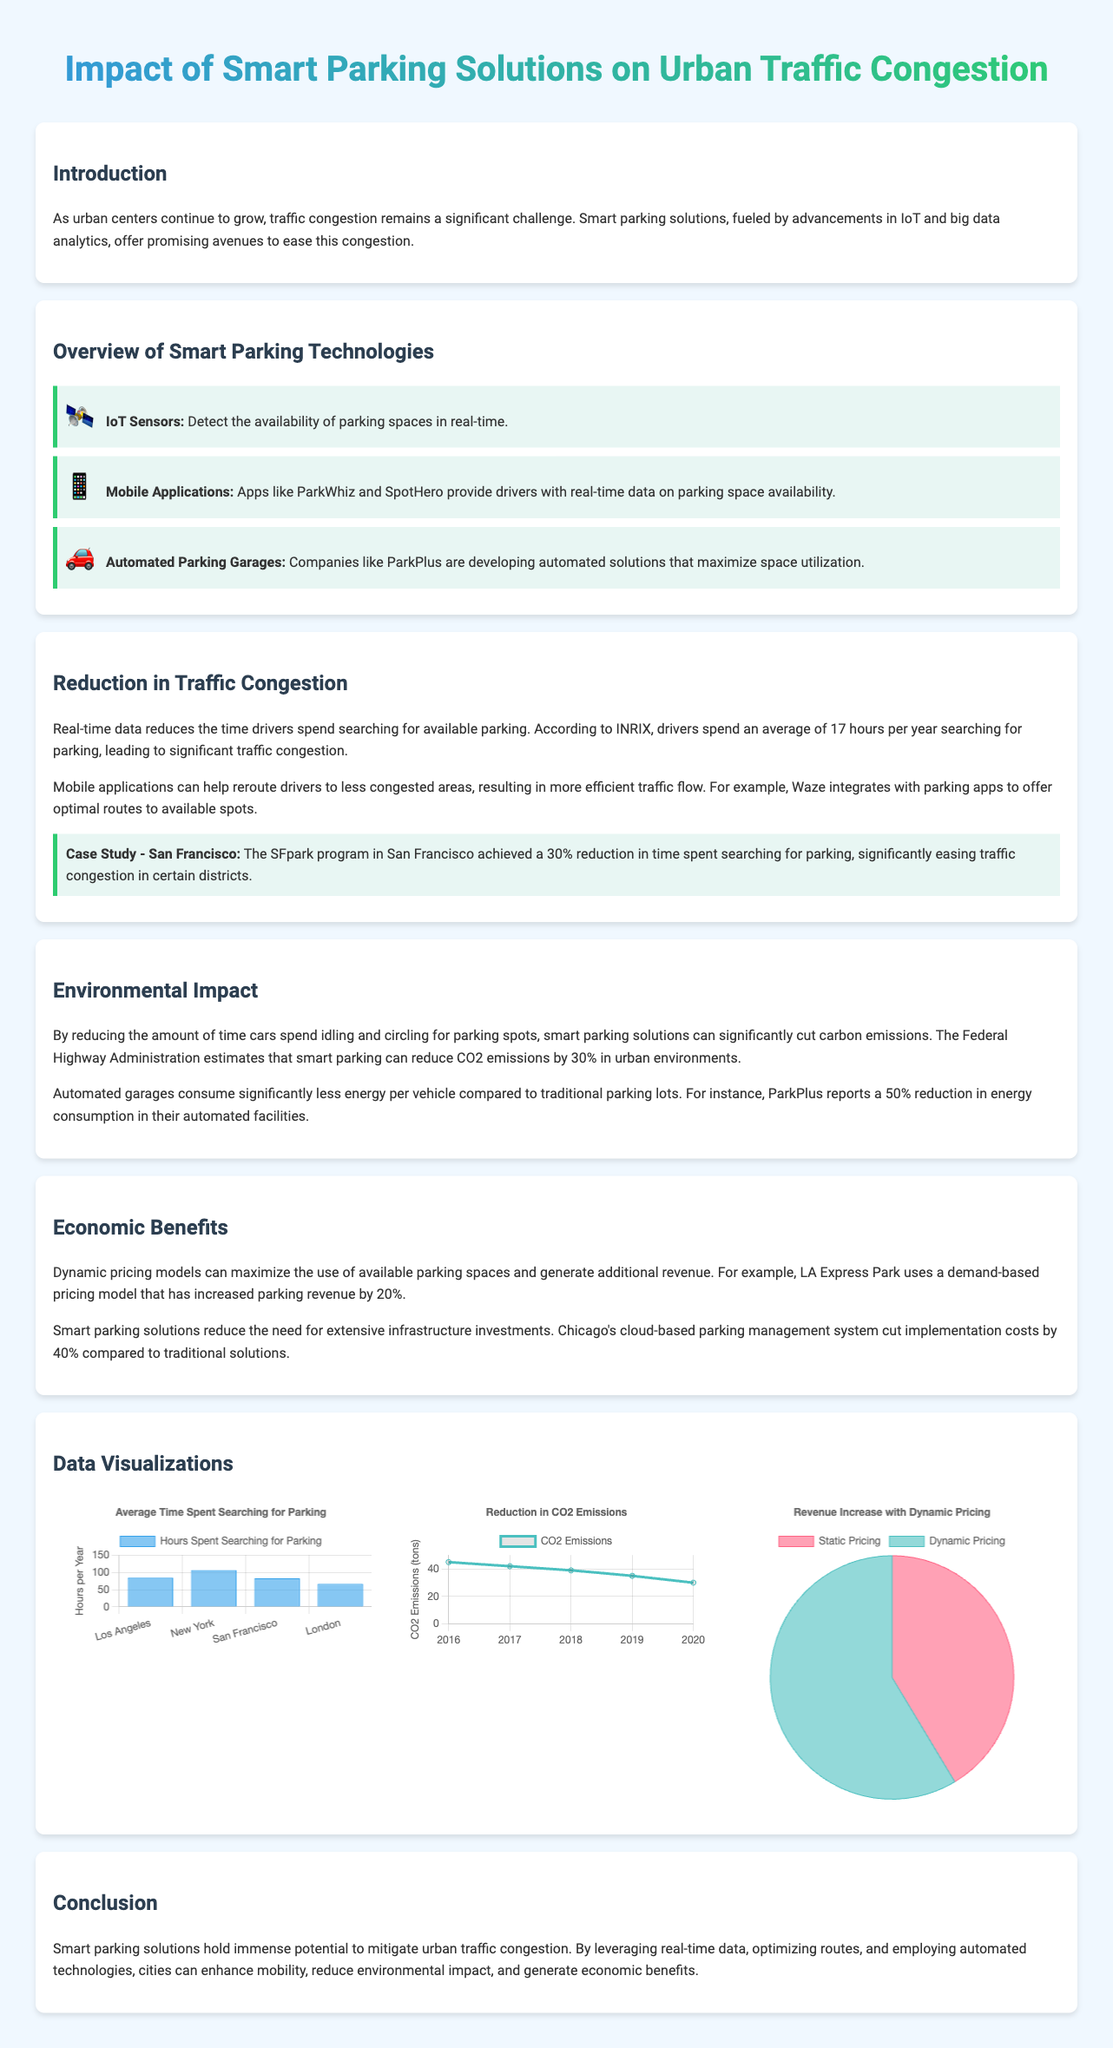What is the average time spent by drivers in Los Angeles searching for parking? The document states that drivers in Los Angeles spend 85 hours per year searching for parking.
Answer: 85 hours What percentage reduction in time spent searching for parking was achieved by the SFpark program? The document mentions a 30% reduction in time spent searching for parking due to the SFpark program.
Answer: 30% What is the CO2 emissions reduction reported in 2020? The data visualization indicates that CO2 emissions were at 30 tons in 2020.
Answer: 30 tons What is the increase in parking revenue due to the LA Express Park's demand-based pricing model? The document states that the demand-based pricing model increased parking revenue by 20%.
Answer: 20% What type of chart shows the average time spent searching for parking? The average time spent searching for parking is represented by a bar chart.
Answer: Bar chart How much energy consumption is reduced in ParkPlus automated facilities compared to traditional parking lots? The document states that ParkPlus reports a 50% reduction in energy consumption in automated facilities.
Answer: 50% What was the CO2 emissions data for the year 2016? The line chart shows that CO2 emissions were 45 tons in 2016.
Answer: 45 tons What are the two pricing models compared in the revenue increase chart? The pricing models compared are Static Pricing and Dynamic Pricing.
Answer: Static Pricing and Dynamic Pricing What year was the first data point recorded for CO2 emissions in the chart? The first data point for CO2 emissions was recorded in 2016.
Answer: 2016 